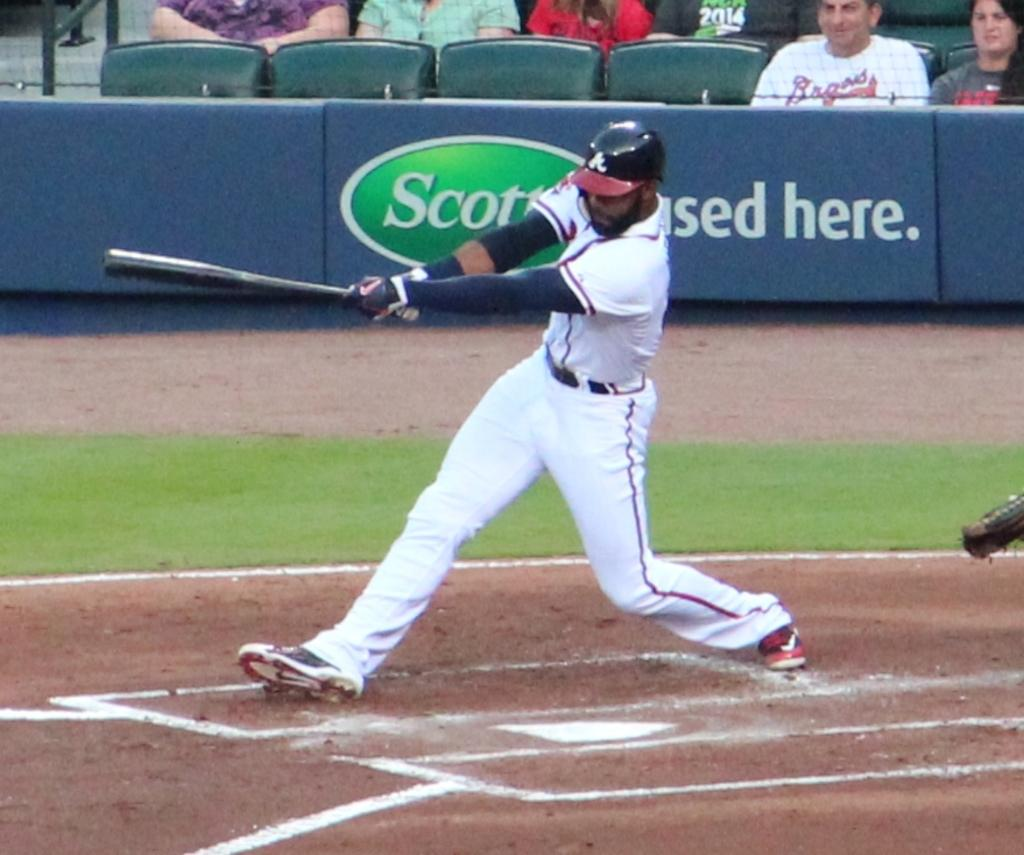<image>
Present a compact description of the photo's key features. A baseball player swings the bat in front of a sign for Scott's-used here. 